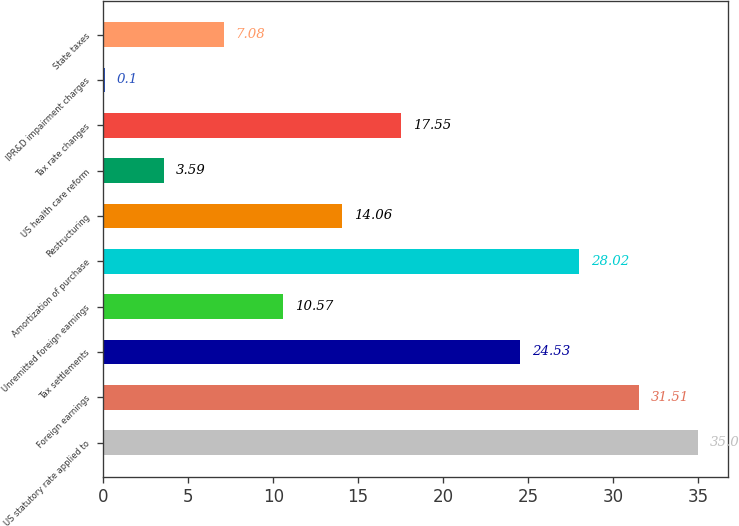Convert chart. <chart><loc_0><loc_0><loc_500><loc_500><bar_chart><fcel>US statutory rate applied to<fcel>Foreign earnings<fcel>Tax settlements<fcel>Unremitted foreign earnings<fcel>Amortization of purchase<fcel>Restructuring<fcel>US health care reform<fcel>Tax rate changes<fcel>IPR&D impairment charges<fcel>State taxes<nl><fcel>35<fcel>31.51<fcel>24.53<fcel>10.57<fcel>28.02<fcel>14.06<fcel>3.59<fcel>17.55<fcel>0.1<fcel>7.08<nl></chart> 